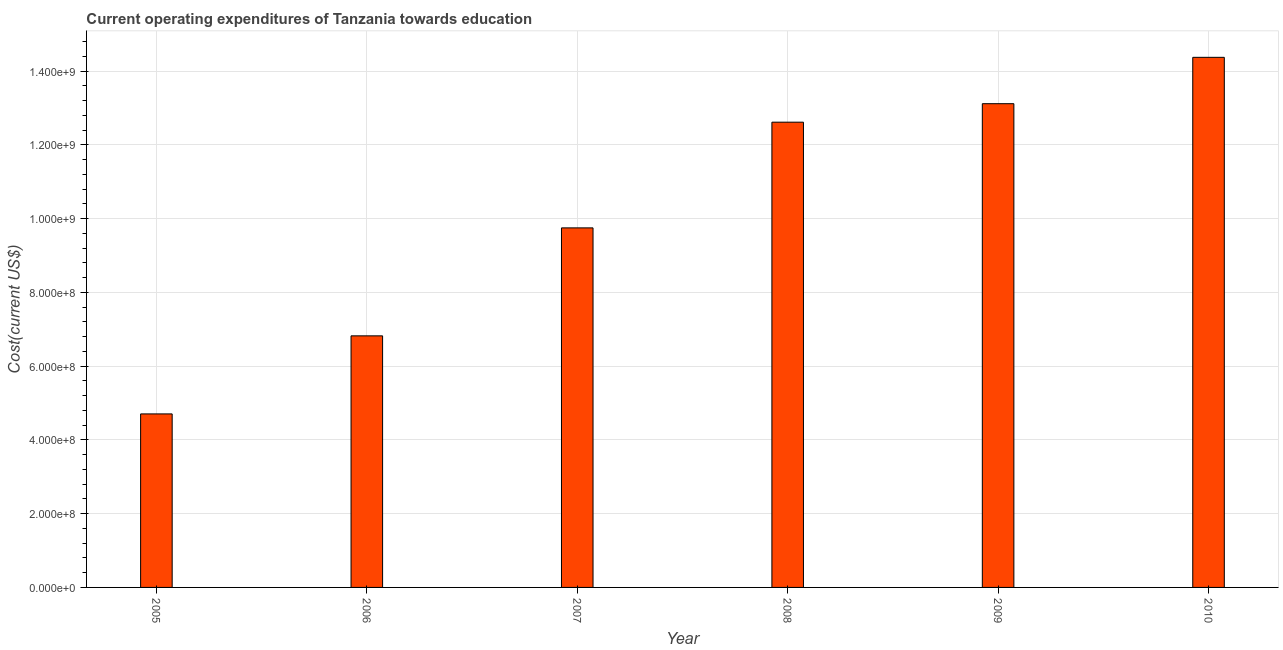Does the graph contain any zero values?
Provide a short and direct response. No. Does the graph contain grids?
Your response must be concise. Yes. What is the title of the graph?
Keep it short and to the point. Current operating expenditures of Tanzania towards education. What is the label or title of the Y-axis?
Provide a succinct answer. Cost(current US$). What is the education expenditure in 2010?
Provide a succinct answer. 1.44e+09. Across all years, what is the maximum education expenditure?
Your answer should be very brief. 1.44e+09. Across all years, what is the minimum education expenditure?
Offer a terse response. 4.70e+08. In which year was the education expenditure maximum?
Give a very brief answer. 2010. What is the sum of the education expenditure?
Provide a succinct answer. 6.14e+09. What is the difference between the education expenditure in 2005 and 2008?
Offer a terse response. -7.91e+08. What is the average education expenditure per year?
Your answer should be very brief. 1.02e+09. What is the median education expenditure?
Ensure brevity in your answer.  1.12e+09. Do a majority of the years between 2010 and 2007 (inclusive) have education expenditure greater than 40000000 US$?
Your response must be concise. Yes. What is the ratio of the education expenditure in 2005 to that in 2010?
Your answer should be very brief. 0.33. Is the difference between the education expenditure in 2005 and 2008 greater than the difference between any two years?
Keep it short and to the point. No. What is the difference between the highest and the second highest education expenditure?
Your answer should be very brief. 1.26e+08. What is the difference between the highest and the lowest education expenditure?
Offer a terse response. 9.67e+08. How many bars are there?
Keep it short and to the point. 6. Are all the bars in the graph horizontal?
Provide a succinct answer. No. Are the values on the major ticks of Y-axis written in scientific E-notation?
Provide a succinct answer. Yes. What is the Cost(current US$) in 2005?
Give a very brief answer. 4.70e+08. What is the Cost(current US$) in 2006?
Make the answer very short. 6.82e+08. What is the Cost(current US$) of 2007?
Your answer should be compact. 9.75e+08. What is the Cost(current US$) in 2008?
Your answer should be very brief. 1.26e+09. What is the Cost(current US$) in 2009?
Your answer should be compact. 1.31e+09. What is the Cost(current US$) in 2010?
Make the answer very short. 1.44e+09. What is the difference between the Cost(current US$) in 2005 and 2006?
Provide a succinct answer. -2.12e+08. What is the difference between the Cost(current US$) in 2005 and 2007?
Your response must be concise. -5.04e+08. What is the difference between the Cost(current US$) in 2005 and 2008?
Your response must be concise. -7.91e+08. What is the difference between the Cost(current US$) in 2005 and 2009?
Give a very brief answer. -8.41e+08. What is the difference between the Cost(current US$) in 2005 and 2010?
Offer a terse response. -9.67e+08. What is the difference between the Cost(current US$) in 2006 and 2007?
Ensure brevity in your answer.  -2.93e+08. What is the difference between the Cost(current US$) in 2006 and 2008?
Provide a succinct answer. -5.79e+08. What is the difference between the Cost(current US$) in 2006 and 2009?
Give a very brief answer. -6.29e+08. What is the difference between the Cost(current US$) in 2006 and 2010?
Give a very brief answer. -7.55e+08. What is the difference between the Cost(current US$) in 2007 and 2008?
Keep it short and to the point. -2.87e+08. What is the difference between the Cost(current US$) in 2007 and 2009?
Offer a very short reply. -3.37e+08. What is the difference between the Cost(current US$) in 2007 and 2010?
Provide a short and direct response. -4.62e+08. What is the difference between the Cost(current US$) in 2008 and 2009?
Your answer should be compact. -5.01e+07. What is the difference between the Cost(current US$) in 2008 and 2010?
Ensure brevity in your answer.  -1.76e+08. What is the difference between the Cost(current US$) in 2009 and 2010?
Provide a succinct answer. -1.26e+08. What is the ratio of the Cost(current US$) in 2005 to that in 2006?
Your answer should be very brief. 0.69. What is the ratio of the Cost(current US$) in 2005 to that in 2007?
Offer a very short reply. 0.48. What is the ratio of the Cost(current US$) in 2005 to that in 2008?
Offer a very short reply. 0.37. What is the ratio of the Cost(current US$) in 2005 to that in 2009?
Your response must be concise. 0.36. What is the ratio of the Cost(current US$) in 2005 to that in 2010?
Keep it short and to the point. 0.33. What is the ratio of the Cost(current US$) in 2006 to that in 2007?
Your answer should be compact. 0.7. What is the ratio of the Cost(current US$) in 2006 to that in 2008?
Provide a short and direct response. 0.54. What is the ratio of the Cost(current US$) in 2006 to that in 2009?
Your response must be concise. 0.52. What is the ratio of the Cost(current US$) in 2006 to that in 2010?
Provide a succinct answer. 0.47. What is the ratio of the Cost(current US$) in 2007 to that in 2008?
Make the answer very short. 0.77. What is the ratio of the Cost(current US$) in 2007 to that in 2009?
Provide a succinct answer. 0.74. What is the ratio of the Cost(current US$) in 2007 to that in 2010?
Offer a very short reply. 0.68. What is the ratio of the Cost(current US$) in 2008 to that in 2010?
Your answer should be very brief. 0.88. What is the ratio of the Cost(current US$) in 2009 to that in 2010?
Your answer should be very brief. 0.91. 